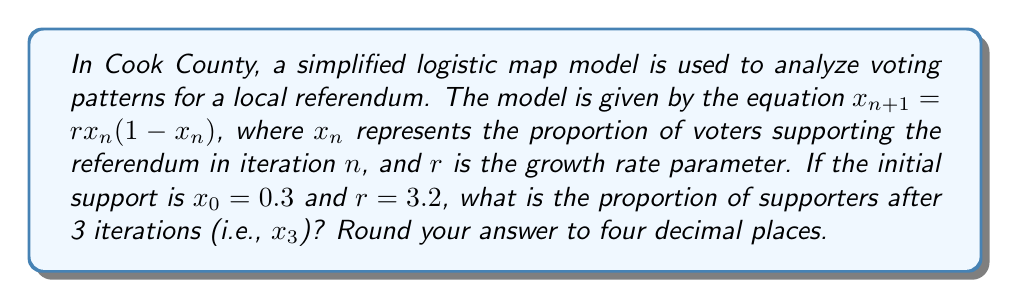What is the answer to this math problem? Let's solve this step-by-step using the logistic map equation:

1) We start with $x_0 = 0.3$ and $r = 3.2$

2) For the first iteration ($n = 0$):
   $x_1 = rx_0(1-x_0)$
   $x_1 = 3.2 \cdot 0.3 \cdot (1-0.3)$
   $x_1 = 3.2 \cdot 0.3 \cdot 0.7 = 0.672$

3) For the second iteration ($n = 1$):
   $x_2 = rx_1(1-x_1)$
   $x_2 = 3.2 \cdot 0.672 \cdot (1-0.672)$
   $x_2 = 3.2 \cdot 0.672 \cdot 0.328 = 0.70532096$

4) For the third iteration ($n = 2$):
   $x_3 = rx_2(1-x_2)$
   $x_3 = 3.2 \cdot 0.70532096 \cdot (1-0.70532096)$
   $x_3 = 3.2 \cdot 0.70532096 \cdot 0.29467904 = 0.66557377$

5) Rounding to four decimal places:
   $x_3 \approx 0.6656$

This final value represents the proportion of voters supporting the referendum after 3 iterations of the logistic map model.
Answer: 0.6656 